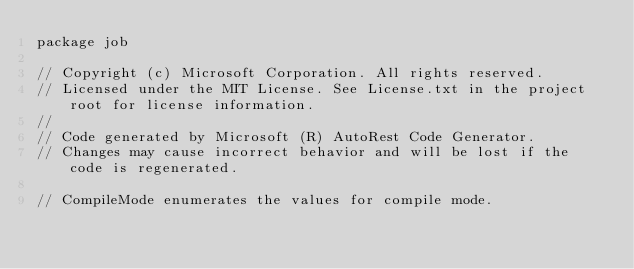Convert code to text. <code><loc_0><loc_0><loc_500><loc_500><_Go_>package job

// Copyright (c) Microsoft Corporation. All rights reserved.
// Licensed under the MIT License. See License.txt in the project root for license information.
//
// Code generated by Microsoft (R) AutoRest Code Generator.
// Changes may cause incorrect behavior and will be lost if the code is regenerated.

// CompileMode enumerates the values for compile mode.</code> 